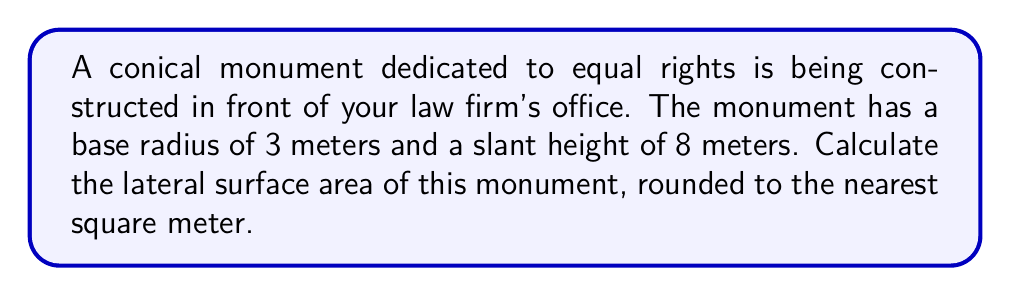Could you help me with this problem? To calculate the lateral surface area of a cone, we need to use the formula:

$$ A = \pi r s $$

Where:
$A$ = lateral surface area
$r$ = radius of the base
$s$ = slant height of the cone

Given:
$r = 3$ meters
$s = 8$ meters

Let's substitute these values into the formula:

$$ A = \pi \cdot 3 \cdot 8 $$

$$ A = 24\pi $$

Using $\pi \approx 3.14159$:

$$ A \approx 24 \cdot 3.14159 $$
$$ A \approx 75.39816 \text{ square meters} $$

Rounding to the nearest square meter:

$$ A \approx 75 \text{ square meters} $$

[asy]
import geometry;

size(200);
pair O=(0,0), A=(3,0), B=(0,8);
draw(O--A--B--O);
draw(arc(O,3,0,90),dashed);
label("3 m",A/2,S);
label("8 m",(O+B)/2,NW);
label("r",A/2,N);
label("s",B/2,SE);
[/asy]
Answer: 75 m² 